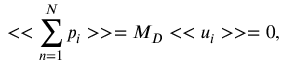<formula> <loc_0><loc_0><loc_500><loc_500>< < \sum _ { n = 1 } ^ { N } p _ { i } > > = M _ { D } < < u _ { i } > > = 0 ,</formula> 